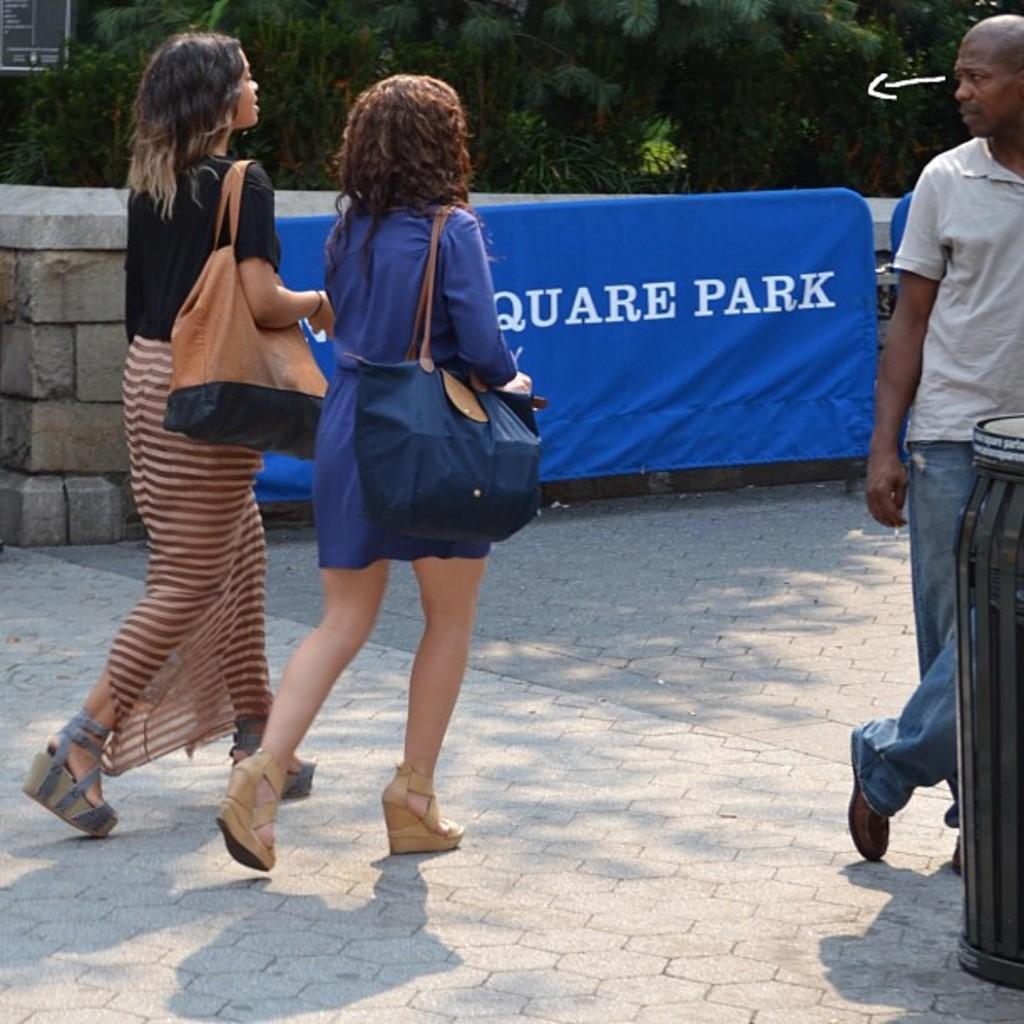Could you give a brief overview of what you see in this image? In this image at the center there are two persons walking on the road. On the right side of the image there is a person standing by holding the dustbin. On the backside there is a wall with the banner attached to it. In the background there are trees. 